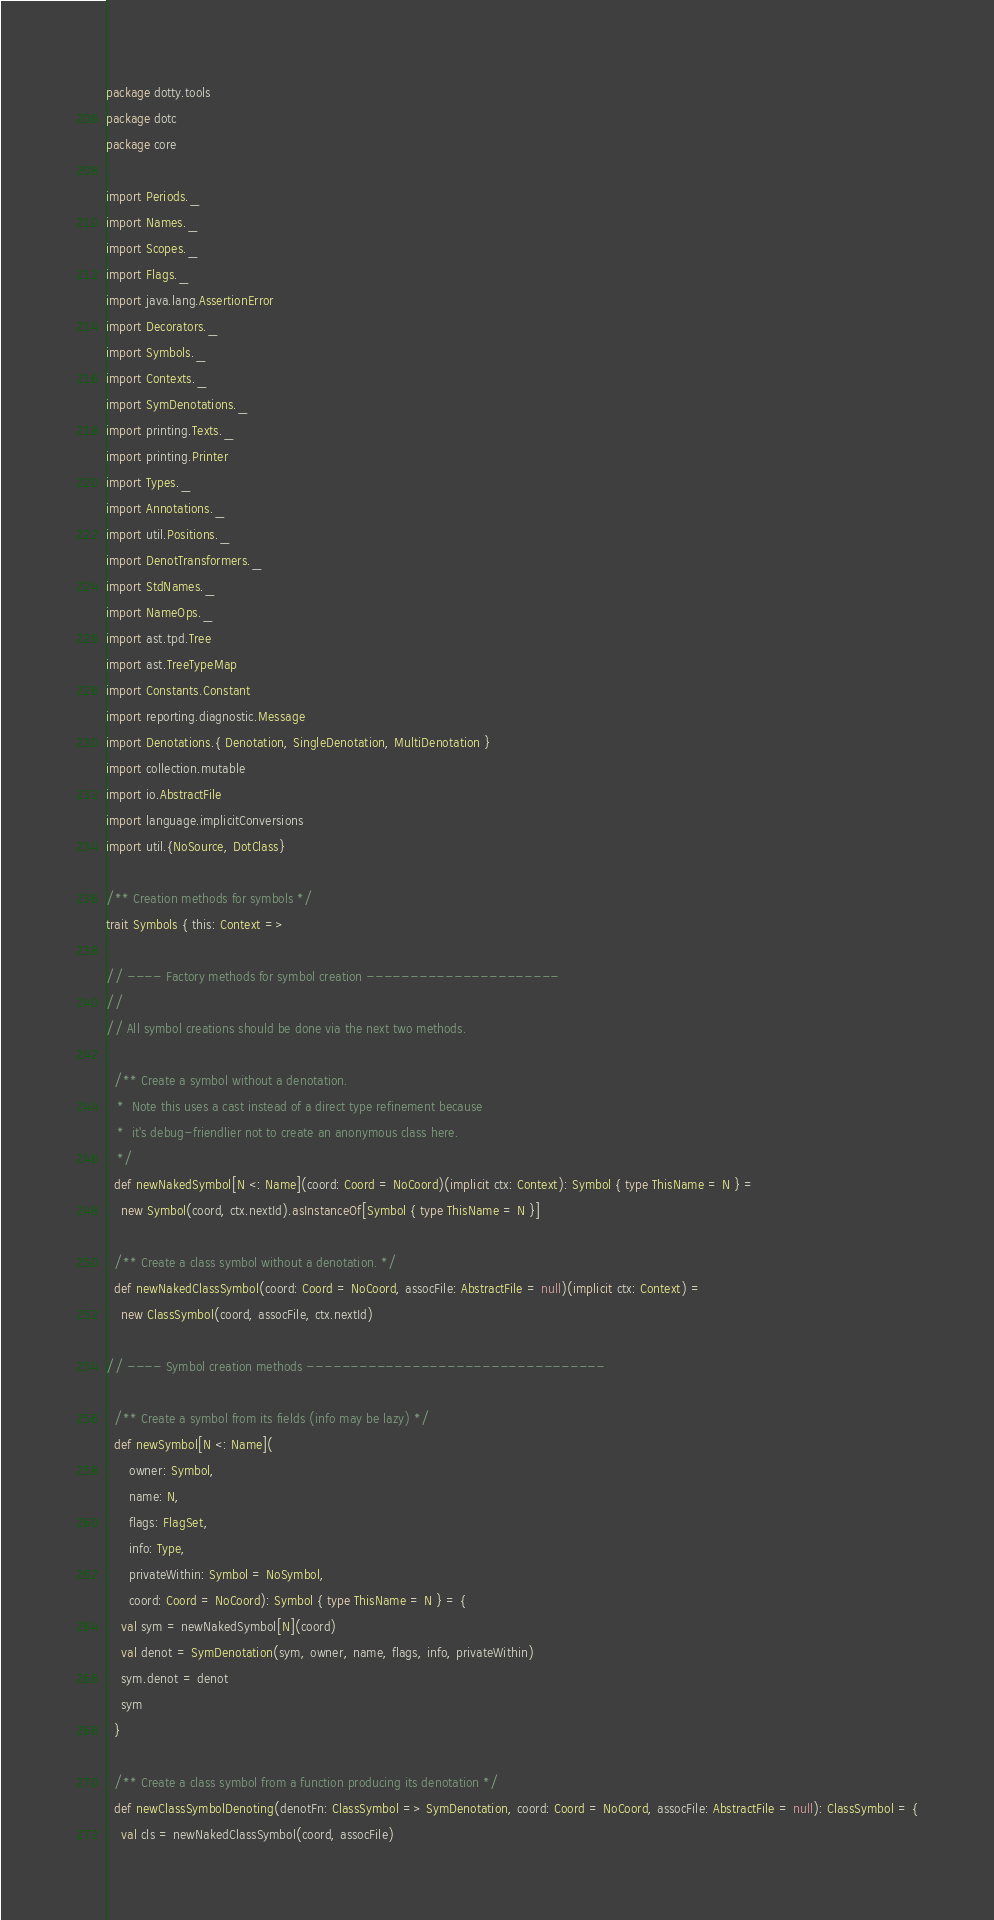Convert code to text. <code><loc_0><loc_0><loc_500><loc_500><_Scala_>package dotty.tools
package dotc
package core

import Periods._
import Names._
import Scopes._
import Flags._
import java.lang.AssertionError
import Decorators._
import Symbols._
import Contexts._
import SymDenotations._
import printing.Texts._
import printing.Printer
import Types._
import Annotations._
import util.Positions._
import DenotTransformers._
import StdNames._
import NameOps._
import ast.tpd.Tree
import ast.TreeTypeMap
import Constants.Constant
import reporting.diagnostic.Message
import Denotations.{ Denotation, SingleDenotation, MultiDenotation }
import collection.mutable
import io.AbstractFile
import language.implicitConversions
import util.{NoSource, DotClass}

/** Creation methods for symbols */
trait Symbols { this: Context =>

// ---- Factory methods for symbol creation ----------------------
//
// All symbol creations should be done via the next two methods.

  /** Create a symbol without a denotation.
   *  Note this uses a cast instead of a direct type refinement because
   *  it's debug-friendlier not to create an anonymous class here.
   */
  def newNakedSymbol[N <: Name](coord: Coord = NoCoord)(implicit ctx: Context): Symbol { type ThisName = N } =
    new Symbol(coord, ctx.nextId).asInstanceOf[Symbol { type ThisName = N }]

  /** Create a class symbol without a denotation. */
  def newNakedClassSymbol(coord: Coord = NoCoord, assocFile: AbstractFile = null)(implicit ctx: Context) =
    new ClassSymbol(coord, assocFile, ctx.nextId)

// ---- Symbol creation methods ----------------------------------

  /** Create a symbol from its fields (info may be lazy) */
  def newSymbol[N <: Name](
      owner: Symbol,
      name: N,
      flags: FlagSet,
      info: Type,
      privateWithin: Symbol = NoSymbol,
      coord: Coord = NoCoord): Symbol { type ThisName = N } = {
    val sym = newNakedSymbol[N](coord)
    val denot = SymDenotation(sym, owner, name, flags, info, privateWithin)
    sym.denot = denot
    sym
  }

  /** Create a class symbol from a function producing its denotation */
  def newClassSymbolDenoting(denotFn: ClassSymbol => SymDenotation, coord: Coord = NoCoord, assocFile: AbstractFile = null): ClassSymbol = {
    val cls = newNakedClassSymbol(coord, assocFile)</code> 